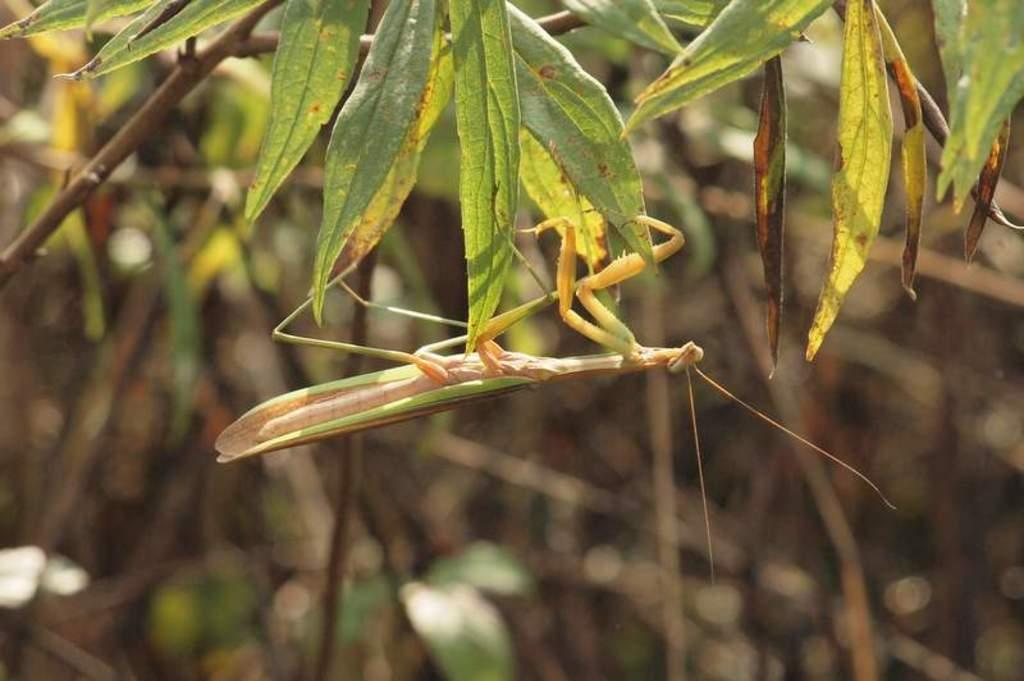What type of insect is in the image? There is a grasshopper in the image. What type of vegetation is present in the image? There are green leaves in the image. Can you describe the background of the image? The background of the image is blurred. What type of map can be seen in the image? There is no map present in the image; it features a grasshopper and green leaves. What type of pickle is visible in the image? There is no pickle present in the image. 